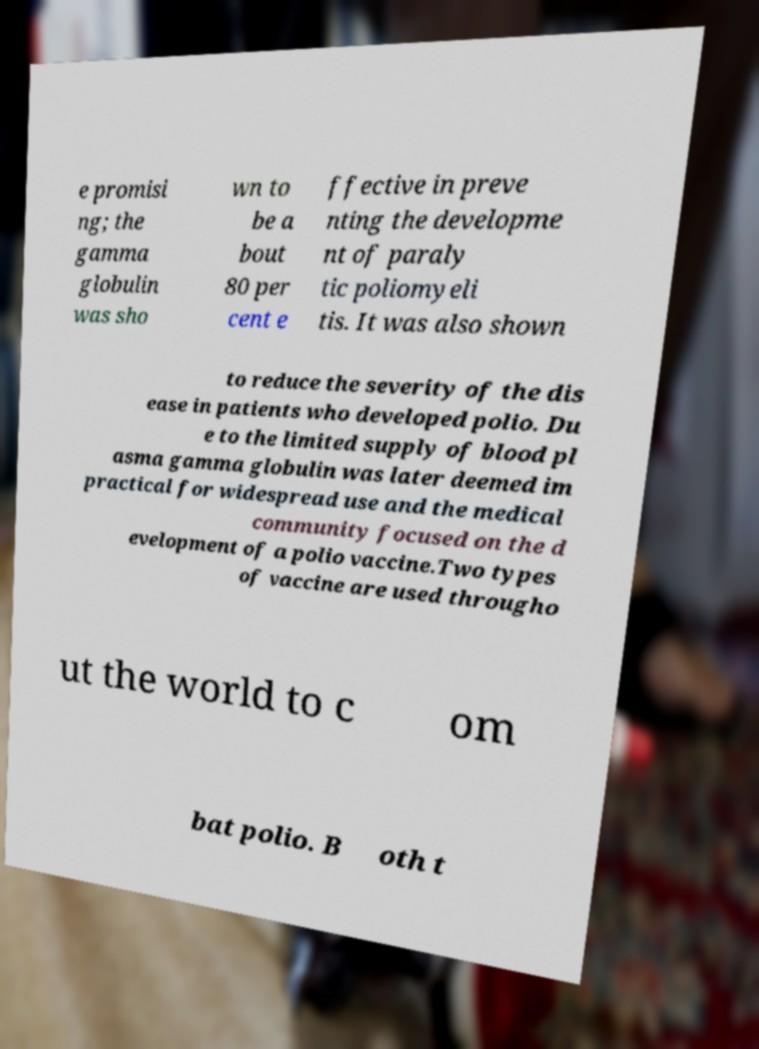Could you assist in decoding the text presented in this image and type it out clearly? e promisi ng; the gamma globulin was sho wn to be a bout 80 per cent e ffective in preve nting the developme nt of paraly tic poliomyeli tis. It was also shown to reduce the severity of the dis ease in patients who developed polio. Du e to the limited supply of blood pl asma gamma globulin was later deemed im practical for widespread use and the medical community focused on the d evelopment of a polio vaccine.Two types of vaccine are used througho ut the world to c om bat polio. B oth t 